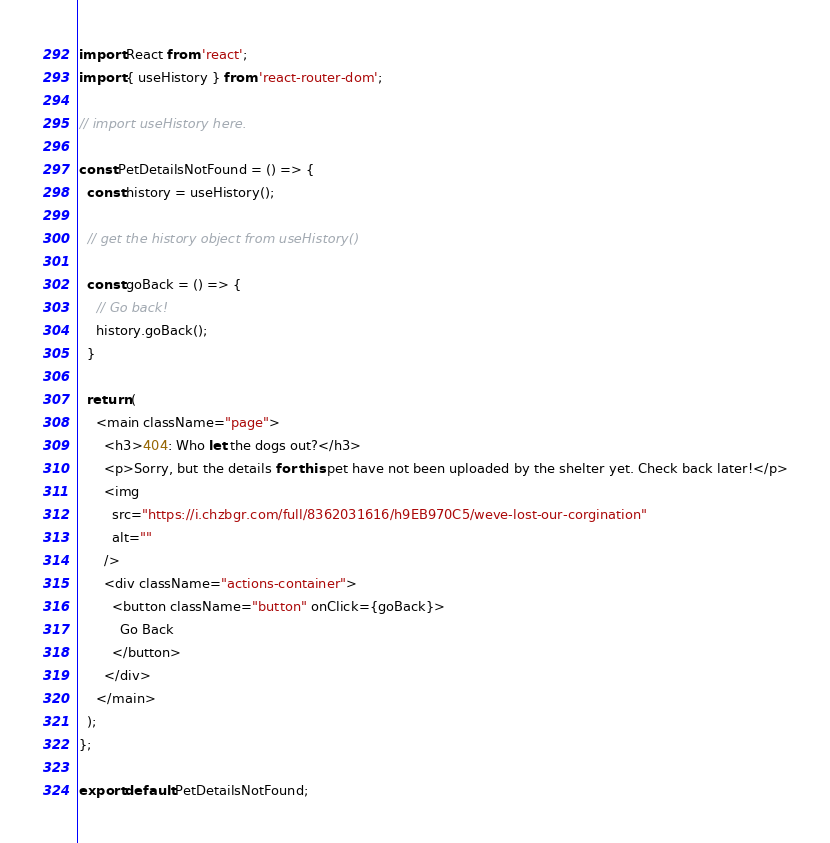Convert code to text. <code><loc_0><loc_0><loc_500><loc_500><_JavaScript_>import React from 'react';
import { useHistory } from 'react-router-dom';

// import useHistory here.

const PetDetailsNotFound = () => {
  const history = useHistory();

  // get the history object from useHistory()

  const goBack = () => {
    // Go back!
    history.goBack();
  }
  
  return (
    <main className="page">
      <h3>404: Who let the dogs out?</h3>
      <p>Sorry, but the details for this pet have not been uploaded by the shelter yet. Check back later!</p>
      <img
        src="https://i.chzbgr.com/full/8362031616/h9EB970C5/weve-lost-our-corgination"
        alt=""
      />
      <div className="actions-container">
        <button className="button" onClick={goBack}>
          Go Back
        </button>
      </div>
    </main>
  );
};

export default PetDetailsNotFound;
</code> 